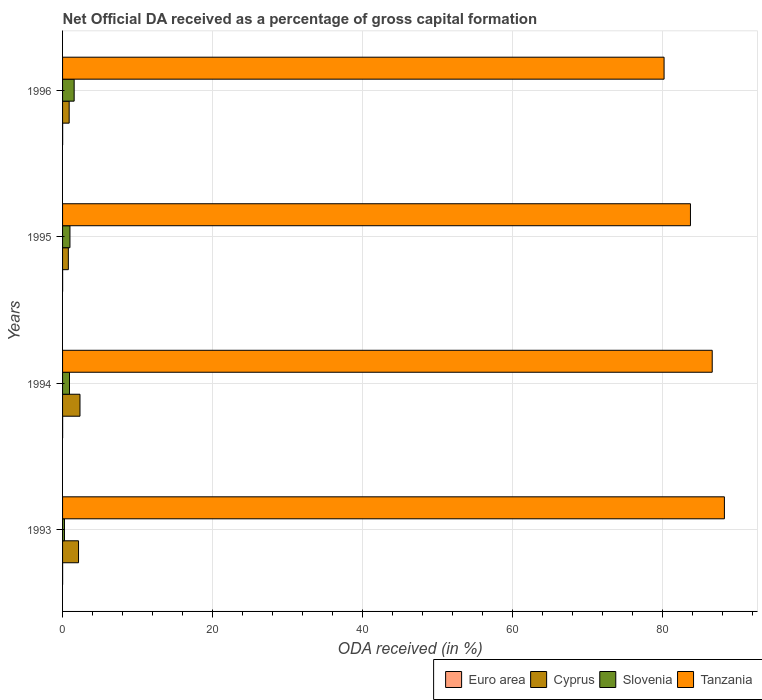How many different coloured bars are there?
Provide a short and direct response. 4. How many groups of bars are there?
Offer a very short reply. 4. Are the number of bars on each tick of the Y-axis equal?
Keep it short and to the point. Yes. How many bars are there on the 2nd tick from the top?
Ensure brevity in your answer.  4. What is the label of the 2nd group of bars from the top?
Your response must be concise. 1995. In how many cases, is the number of bars for a given year not equal to the number of legend labels?
Your answer should be very brief. 0. What is the net ODA received in Slovenia in 1996?
Provide a short and direct response. 1.55. Across all years, what is the maximum net ODA received in Slovenia?
Keep it short and to the point. 1.55. Across all years, what is the minimum net ODA received in Slovenia?
Provide a succinct answer. 0.25. In which year was the net ODA received in Euro area minimum?
Keep it short and to the point. 1995. What is the total net ODA received in Cyprus in the graph?
Provide a succinct answer. 6.11. What is the difference between the net ODA received in Cyprus in 1995 and that in 1996?
Provide a succinct answer. -0.11. What is the difference between the net ODA received in Euro area in 1994 and the net ODA received in Slovenia in 1993?
Your response must be concise. -0.25. What is the average net ODA received in Euro area per year?
Give a very brief answer. 0.01. In the year 1996, what is the difference between the net ODA received in Slovenia and net ODA received in Euro area?
Offer a very short reply. 1.54. What is the ratio of the net ODA received in Tanzania in 1993 to that in 1994?
Give a very brief answer. 1.02. Is the difference between the net ODA received in Slovenia in 1993 and 1995 greater than the difference between the net ODA received in Euro area in 1993 and 1995?
Your answer should be very brief. No. What is the difference between the highest and the second highest net ODA received in Cyprus?
Ensure brevity in your answer.  0.19. What is the difference between the highest and the lowest net ODA received in Cyprus?
Give a very brief answer. 1.55. In how many years, is the net ODA received in Cyprus greater than the average net ODA received in Cyprus taken over all years?
Provide a succinct answer. 2. What does the 3rd bar from the top in 1996 represents?
Your response must be concise. Cyprus. What does the 4th bar from the bottom in 1996 represents?
Your answer should be very brief. Tanzania. What is the difference between two consecutive major ticks on the X-axis?
Make the answer very short. 20. Are the values on the major ticks of X-axis written in scientific E-notation?
Give a very brief answer. No. What is the title of the graph?
Offer a terse response. Net Official DA received as a percentage of gross capital formation. Does "Middle East & North Africa (all income levels)" appear as one of the legend labels in the graph?
Keep it short and to the point. No. What is the label or title of the X-axis?
Your answer should be compact. ODA received (in %). What is the ODA received (in %) in Euro area in 1993?
Ensure brevity in your answer.  0.01. What is the ODA received (in %) of Cyprus in 1993?
Keep it short and to the point. 2.13. What is the ODA received (in %) of Slovenia in 1993?
Provide a short and direct response. 0.25. What is the ODA received (in %) in Tanzania in 1993?
Your answer should be compact. 88.28. What is the ODA received (in %) of Euro area in 1994?
Your response must be concise. 0.01. What is the ODA received (in %) in Cyprus in 1994?
Offer a terse response. 2.32. What is the ODA received (in %) of Slovenia in 1994?
Your answer should be very brief. 0.92. What is the ODA received (in %) in Tanzania in 1994?
Provide a short and direct response. 86.66. What is the ODA received (in %) of Euro area in 1995?
Give a very brief answer. 0.01. What is the ODA received (in %) of Cyprus in 1995?
Give a very brief answer. 0.77. What is the ODA received (in %) in Slovenia in 1995?
Your answer should be very brief. 0.98. What is the ODA received (in %) in Tanzania in 1995?
Your answer should be compact. 83.75. What is the ODA received (in %) of Euro area in 1996?
Ensure brevity in your answer.  0.01. What is the ODA received (in %) of Cyprus in 1996?
Provide a short and direct response. 0.88. What is the ODA received (in %) of Slovenia in 1996?
Offer a terse response. 1.55. What is the ODA received (in %) of Tanzania in 1996?
Your answer should be compact. 80.24. Across all years, what is the maximum ODA received (in %) in Euro area?
Provide a short and direct response. 0.01. Across all years, what is the maximum ODA received (in %) of Cyprus?
Give a very brief answer. 2.32. Across all years, what is the maximum ODA received (in %) of Slovenia?
Provide a short and direct response. 1.55. Across all years, what is the maximum ODA received (in %) in Tanzania?
Offer a terse response. 88.28. Across all years, what is the minimum ODA received (in %) in Euro area?
Offer a terse response. 0.01. Across all years, what is the minimum ODA received (in %) in Cyprus?
Offer a terse response. 0.77. Across all years, what is the minimum ODA received (in %) of Slovenia?
Your answer should be compact. 0.25. Across all years, what is the minimum ODA received (in %) of Tanzania?
Your answer should be very brief. 80.24. What is the total ODA received (in %) of Euro area in the graph?
Give a very brief answer. 0.03. What is the total ODA received (in %) in Cyprus in the graph?
Provide a short and direct response. 6.11. What is the total ODA received (in %) of Slovenia in the graph?
Give a very brief answer. 3.71. What is the total ODA received (in %) in Tanzania in the graph?
Ensure brevity in your answer.  338.94. What is the difference between the ODA received (in %) of Euro area in 1993 and that in 1994?
Ensure brevity in your answer.  -0. What is the difference between the ODA received (in %) of Cyprus in 1993 and that in 1994?
Provide a succinct answer. -0.19. What is the difference between the ODA received (in %) of Slovenia in 1993 and that in 1994?
Keep it short and to the point. -0.67. What is the difference between the ODA received (in %) of Tanzania in 1993 and that in 1994?
Your response must be concise. 1.62. What is the difference between the ODA received (in %) in Euro area in 1993 and that in 1995?
Make the answer very short. 0. What is the difference between the ODA received (in %) in Cyprus in 1993 and that in 1995?
Give a very brief answer. 1.36. What is the difference between the ODA received (in %) in Slovenia in 1993 and that in 1995?
Your answer should be very brief. -0.73. What is the difference between the ODA received (in %) in Tanzania in 1993 and that in 1995?
Provide a short and direct response. 4.53. What is the difference between the ODA received (in %) in Euro area in 1993 and that in 1996?
Offer a terse response. -0.01. What is the difference between the ODA received (in %) in Cyprus in 1993 and that in 1996?
Make the answer very short. 1.25. What is the difference between the ODA received (in %) of Slovenia in 1993 and that in 1996?
Your answer should be very brief. -1.29. What is the difference between the ODA received (in %) of Tanzania in 1993 and that in 1996?
Your answer should be compact. 8.05. What is the difference between the ODA received (in %) in Euro area in 1994 and that in 1995?
Give a very brief answer. 0. What is the difference between the ODA received (in %) of Cyprus in 1994 and that in 1995?
Provide a short and direct response. 1.55. What is the difference between the ODA received (in %) in Slovenia in 1994 and that in 1995?
Give a very brief answer. -0.06. What is the difference between the ODA received (in %) of Tanzania in 1994 and that in 1995?
Your response must be concise. 2.9. What is the difference between the ODA received (in %) in Euro area in 1994 and that in 1996?
Your answer should be compact. -0. What is the difference between the ODA received (in %) of Cyprus in 1994 and that in 1996?
Offer a very short reply. 1.44. What is the difference between the ODA received (in %) in Slovenia in 1994 and that in 1996?
Ensure brevity in your answer.  -0.62. What is the difference between the ODA received (in %) in Tanzania in 1994 and that in 1996?
Make the answer very short. 6.42. What is the difference between the ODA received (in %) of Euro area in 1995 and that in 1996?
Offer a very short reply. -0.01. What is the difference between the ODA received (in %) in Cyprus in 1995 and that in 1996?
Make the answer very short. -0.11. What is the difference between the ODA received (in %) in Slovenia in 1995 and that in 1996?
Ensure brevity in your answer.  -0.56. What is the difference between the ODA received (in %) in Tanzania in 1995 and that in 1996?
Give a very brief answer. 3.52. What is the difference between the ODA received (in %) in Euro area in 1993 and the ODA received (in %) in Cyprus in 1994?
Your answer should be compact. -2.32. What is the difference between the ODA received (in %) in Euro area in 1993 and the ODA received (in %) in Slovenia in 1994?
Ensure brevity in your answer.  -0.92. What is the difference between the ODA received (in %) in Euro area in 1993 and the ODA received (in %) in Tanzania in 1994?
Provide a succinct answer. -86.65. What is the difference between the ODA received (in %) of Cyprus in 1993 and the ODA received (in %) of Slovenia in 1994?
Your answer should be compact. 1.21. What is the difference between the ODA received (in %) of Cyprus in 1993 and the ODA received (in %) of Tanzania in 1994?
Provide a short and direct response. -84.53. What is the difference between the ODA received (in %) of Slovenia in 1993 and the ODA received (in %) of Tanzania in 1994?
Offer a very short reply. -86.41. What is the difference between the ODA received (in %) of Euro area in 1993 and the ODA received (in %) of Cyprus in 1995?
Your response must be concise. -0.77. What is the difference between the ODA received (in %) in Euro area in 1993 and the ODA received (in %) in Slovenia in 1995?
Your response must be concise. -0.98. What is the difference between the ODA received (in %) in Euro area in 1993 and the ODA received (in %) in Tanzania in 1995?
Give a very brief answer. -83.75. What is the difference between the ODA received (in %) of Cyprus in 1993 and the ODA received (in %) of Slovenia in 1995?
Give a very brief answer. 1.14. What is the difference between the ODA received (in %) in Cyprus in 1993 and the ODA received (in %) in Tanzania in 1995?
Make the answer very short. -81.63. What is the difference between the ODA received (in %) of Slovenia in 1993 and the ODA received (in %) of Tanzania in 1995?
Make the answer very short. -83.5. What is the difference between the ODA received (in %) in Euro area in 1993 and the ODA received (in %) in Cyprus in 1996?
Offer a terse response. -0.88. What is the difference between the ODA received (in %) in Euro area in 1993 and the ODA received (in %) in Slovenia in 1996?
Offer a very short reply. -1.54. What is the difference between the ODA received (in %) of Euro area in 1993 and the ODA received (in %) of Tanzania in 1996?
Provide a short and direct response. -80.23. What is the difference between the ODA received (in %) of Cyprus in 1993 and the ODA received (in %) of Slovenia in 1996?
Your answer should be very brief. 0.58. What is the difference between the ODA received (in %) of Cyprus in 1993 and the ODA received (in %) of Tanzania in 1996?
Provide a short and direct response. -78.11. What is the difference between the ODA received (in %) of Slovenia in 1993 and the ODA received (in %) of Tanzania in 1996?
Offer a terse response. -79.98. What is the difference between the ODA received (in %) of Euro area in 1994 and the ODA received (in %) of Cyprus in 1995?
Your response must be concise. -0.76. What is the difference between the ODA received (in %) of Euro area in 1994 and the ODA received (in %) of Slovenia in 1995?
Provide a short and direct response. -0.98. What is the difference between the ODA received (in %) of Euro area in 1994 and the ODA received (in %) of Tanzania in 1995?
Your answer should be very brief. -83.75. What is the difference between the ODA received (in %) in Cyprus in 1994 and the ODA received (in %) in Slovenia in 1995?
Make the answer very short. 1.34. What is the difference between the ODA received (in %) in Cyprus in 1994 and the ODA received (in %) in Tanzania in 1995?
Make the answer very short. -81.43. What is the difference between the ODA received (in %) in Slovenia in 1994 and the ODA received (in %) in Tanzania in 1995?
Your answer should be compact. -82.83. What is the difference between the ODA received (in %) in Euro area in 1994 and the ODA received (in %) in Cyprus in 1996?
Your answer should be compact. -0.87. What is the difference between the ODA received (in %) of Euro area in 1994 and the ODA received (in %) of Slovenia in 1996?
Provide a short and direct response. -1.54. What is the difference between the ODA received (in %) of Euro area in 1994 and the ODA received (in %) of Tanzania in 1996?
Offer a terse response. -80.23. What is the difference between the ODA received (in %) of Cyprus in 1994 and the ODA received (in %) of Slovenia in 1996?
Your answer should be very brief. 0.78. What is the difference between the ODA received (in %) in Cyprus in 1994 and the ODA received (in %) in Tanzania in 1996?
Your answer should be compact. -77.91. What is the difference between the ODA received (in %) of Slovenia in 1994 and the ODA received (in %) of Tanzania in 1996?
Your response must be concise. -79.31. What is the difference between the ODA received (in %) of Euro area in 1995 and the ODA received (in %) of Cyprus in 1996?
Ensure brevity in your answer.  -0.88. What is the difference between the ODA received (in %) in Euro area in 1995 and the ODA received (in %) in Slovenia in 1996?
Make the answer very short. -1.54. What is the difference between the ODA received (in %) of Euro area in 1995 and the ODA received (in %) of Tanzania in 1996?
Make the answer very short. -80.23. What is the difference between the ODA received (in %) of Cyprus in 1995 and the ODA received (in %) of Slovenia in 1996?
Keep it short and to the point. -0.78. What is the difference between the ODA received (in %) of Cyprus in 1995 and the ODA received (in %) of Tanzania in 1996?
Keep it short and to the point. -79.47. What is the difference between the ODA received (in %) of Slovenia in 1995 and the ODA received (in %) of Tanzania in 1996?
Ensure brevity in your answer.  -79.25. What is the average ODA received (in %) of Euro area per year?
Make the answer very short. 0.01. What is the average ODA received (in %) in Cyprus per year?
Make the answer very short. 1.53. What is the average ODA received (in %) of Slovenia per year?
Ensure brevity in your answer.  0.93. What is the average ODA received (in %) in Tanzania per year?
Offer a terse response. 84.73. In the year 1993, what is the difference between the ODA received (in %) in Euro area and ODA received (in %) in Cyprus?
Your answer should be very brief. -2.12. In the year 1993, what is the difference between the ODA received (in %) in Euro area and ODA received (in %) in Slovenia?
Your answer should be compact. -0.25. In the year 1993, what is the difference between the ODA received (in %) in Euro area and ODA received (in %) in Tanzania?
Keep it short and to the point. -88.28. In the year 1993, what is the difference between the ODA received (in %) in Cyprus and ODA received (in %) in Slovenia?
Give a very brief answer. 1.87. In the year 1993, what is the difference between the ODA received (in %) of Cyprus and ODA received (in %) of Tanzania?
Ensure brevity in your answer.  -86.15. In the year 1993, what is the difference between the ODA received (in %) in Slovenia and ODA received (in %) in Tanzania?
Your response must be concise. -88.03. In the year 1994, what is the difference between the ODA received (in %) in Euro area and ODA received (in %) in Cyprus?
Your answer should be very brief. -2.32. In the year 1994, what is the difference between the ODA received (in %) in Euro area and ODA received (in %) in Slovenia?
Provide a short and direct response. -0.92. In the year 1994, what is the difference between the ODA received (in %) of Euro area and ODA received (in %) of Tanzania?
Provide a succinct answer. -86.65. In the year 1994, what is the difference between the ODA received (in %) in Cyprus and ODA received (in %) in Slovenia?
Your response must be concise. 1.4. In the year 1994, what is the difference between the ODA received (in %) in Cyprus and ODA received (in %) in Tanzania?
Offer a terse response. -84.34. In the year 1994, what is the difference between the ODA received (in %) of Slovenia and ODA received (in %) of Tanzania?
Your answer should be very brief. -85.74. In the year 1995, what is the difference between the ODA received (in %) in Euro area and ODA received (in %) in Cyprus?
Give a very brief answer. -0.77. In the year 1995, what is the difference between the ODA received (in %) of Euro area and ODA received (in %) of Slovenia?
Offer a terse response. -0.98. In the year 1995, what is the difference between the ODA received (in %) in Euro area and ODA received (in %) in Tanzania?
Make the answer very short. -83.75. In the year 1995, what is the difference between the ODA received (in %) of Cyprus and ODA received (in %) of Slovenia?
Give a very brief answer. -0.21. In the year 1995, what is the difference between the ODA received (in %) in Cyprus and ODA received (in %) in Tanzania?
Ensure brevity in your answer.  -82.98. In the year 1995, what is the difference between the ODA received (in %) of Slovenia and ODA received (in %) of Tanzania?
Your response must be concise. -82.77. In the year 1996, what is the difference between the ODA received (in %) of Euro area and ODA received (in %) of Cyprus?
Keep it short and to the point. -0.87. In the year 1996, what is the difference between the ODA received (in %) of Euro area and ODA received (in %) of Slovenia?
Offer a terse response. -1.54. In the year 1996, what is the difference between the ODA received (in %) in Euro area and ODA received (in %) in Tanzania?
Provide a succinct answer. -80.23. In the year 1996, what is the difference between the ODA received (in %) of Cyprus and ODA received (in %) of Slovenia?
Your answer should be very brief. -0.67. In the year 1996, what is the difference between the ODA received (in %) of Cyprus and ODA received (in %) of Tanzania?
Make the answer very short. -79.36. In the year 1996, what is the difference between the ODA received (in %) in Slovenia and ODA received (in %) in Tanzania?
Give a very brief answer. -78.69. What is the ratio of the ODA received (in %) of Euro area in 1993 to that in 1994?
Your answer should be compact. 0.65. What is the ratio of the ODA received (in %) of Cyprus in 1993 to that in 1994?
Give a very brief answer. 0.92. What is the ratio of the ODA received (in %) of Slovenia in 1993 to that in 1994?
Your response must be concise. 0.28. What is the ratio of the ODA received (in %) in Tanzania in 1993 to that in 1994?
Ensure brevity in your answer.  1.02. What is the ratio of the ODA received (in %) in Euro area in 1993 to that in 1995?
Your answer should be compact. 1.09. What is the ratio of the ODA received (in %) in Cyprus in 1993 to that in 1995?
Keep it short and to the point. 2.76. What is the ratio of the ODA received (in %) in Slovenia in 1993 to that in 1995?
Your answer should be compact. 0.26. What is the ratio of the ODA received (in %) in Tanzania in 1993 to that in 1995?
Offer a very short reply. 1.05. What is the ratio of the ODA received (in %) of Euro area in 1993 to that in 1996?
Keep it short and to the point. 0.5. What is the ratio of the ODA received (in %) in Cyprus in 1993 to that in 1996?
Ensure brevity in your answer.  2.42. What is the ratio of the ODA received (in %) in Slovenia in 1993 to that in 1996?
Provide a short and direct response. 0.16. What is the ratio of the ODA received (in %) in Tanzania in 1993 to that in 1996?
Offer a terse response. 1.1. What is the ratio of the ODA received (in %) in Euro area in 1994 to that in 1995?
Offer a terse response. 1.67. What is the ratio of the ODA received (in %) of Cyprus in 1994 to that in 1995?
Make the answer very short. 3.01. What is the ratio of the ODA received (in %) in Slovenia in 1994 to that in 1995?
Your response must be concise. 0.94. What is the ratio of the ODA received (in %) in Tanzania in 1994 to that in 1995?
Provide a short and direct response. 1.03. What is the ratio of the ODA received (in %) of Euro area in 1994 to that in 1996?
Keep it short and to the point. 0.77. What is the ratio of the ODA received (in %) in Cyprus in 1994 to that in 1996?
Provide a succinct answer. 2.64. What is the ratio of the ODA received (in %) in Slovenia in 1994 to that in 1996?
Your response must be concise. 0.6. What is the ratio of the ODA received (in %) of Euro area in 1995 to that in 1996?
Ensure brevity in your answer.  0.46. What is the ratio of the ODA received (in %) in Cyprus in 1995 to that in 1996?
Keep it short and to the point. 0.87. What is the ratio of the ODA received (in %) of Slovenia in 1995 to that in 1996?
Provide a succinct answer. 0.64. What is the ratio of the ODA received (in %) in Tanzania in 1995 to that in 1996?
Keep it short and to the point. 1.04. What is the difference between the highest and the second highest ODA received (in %) in Euro area?
Offer a terse response. 0. What is the difference between the highest and the second highest ODA received (in %) in Cyprus?
Provide a succinct answer. 0.19. What is the difference between the highest and the second highest ODA received (in %) in Slovenia?
Your answer should be compact. 0.56. What is the difference between the highest and the second highest ODA received (in %) of Tanzania?
Provide a short and direct response. 1.62. What is the difference between the highest and the lowest ODA received (in %) of Euro area?
Give a very brief answer. 0.01. What is the difference between the highest and the lowest ODA received (in %) in Cyprus?
Provide a short and direct response. 1.55. What is the difference between the highest and the lowest ODA received (in %) of Slovenia?
Ensure brevity in your answer.  1.29. What is the difference between the highest and the lowest ODA received (in %) in Tanzania?
Provide a short and direct response. 8.05. 